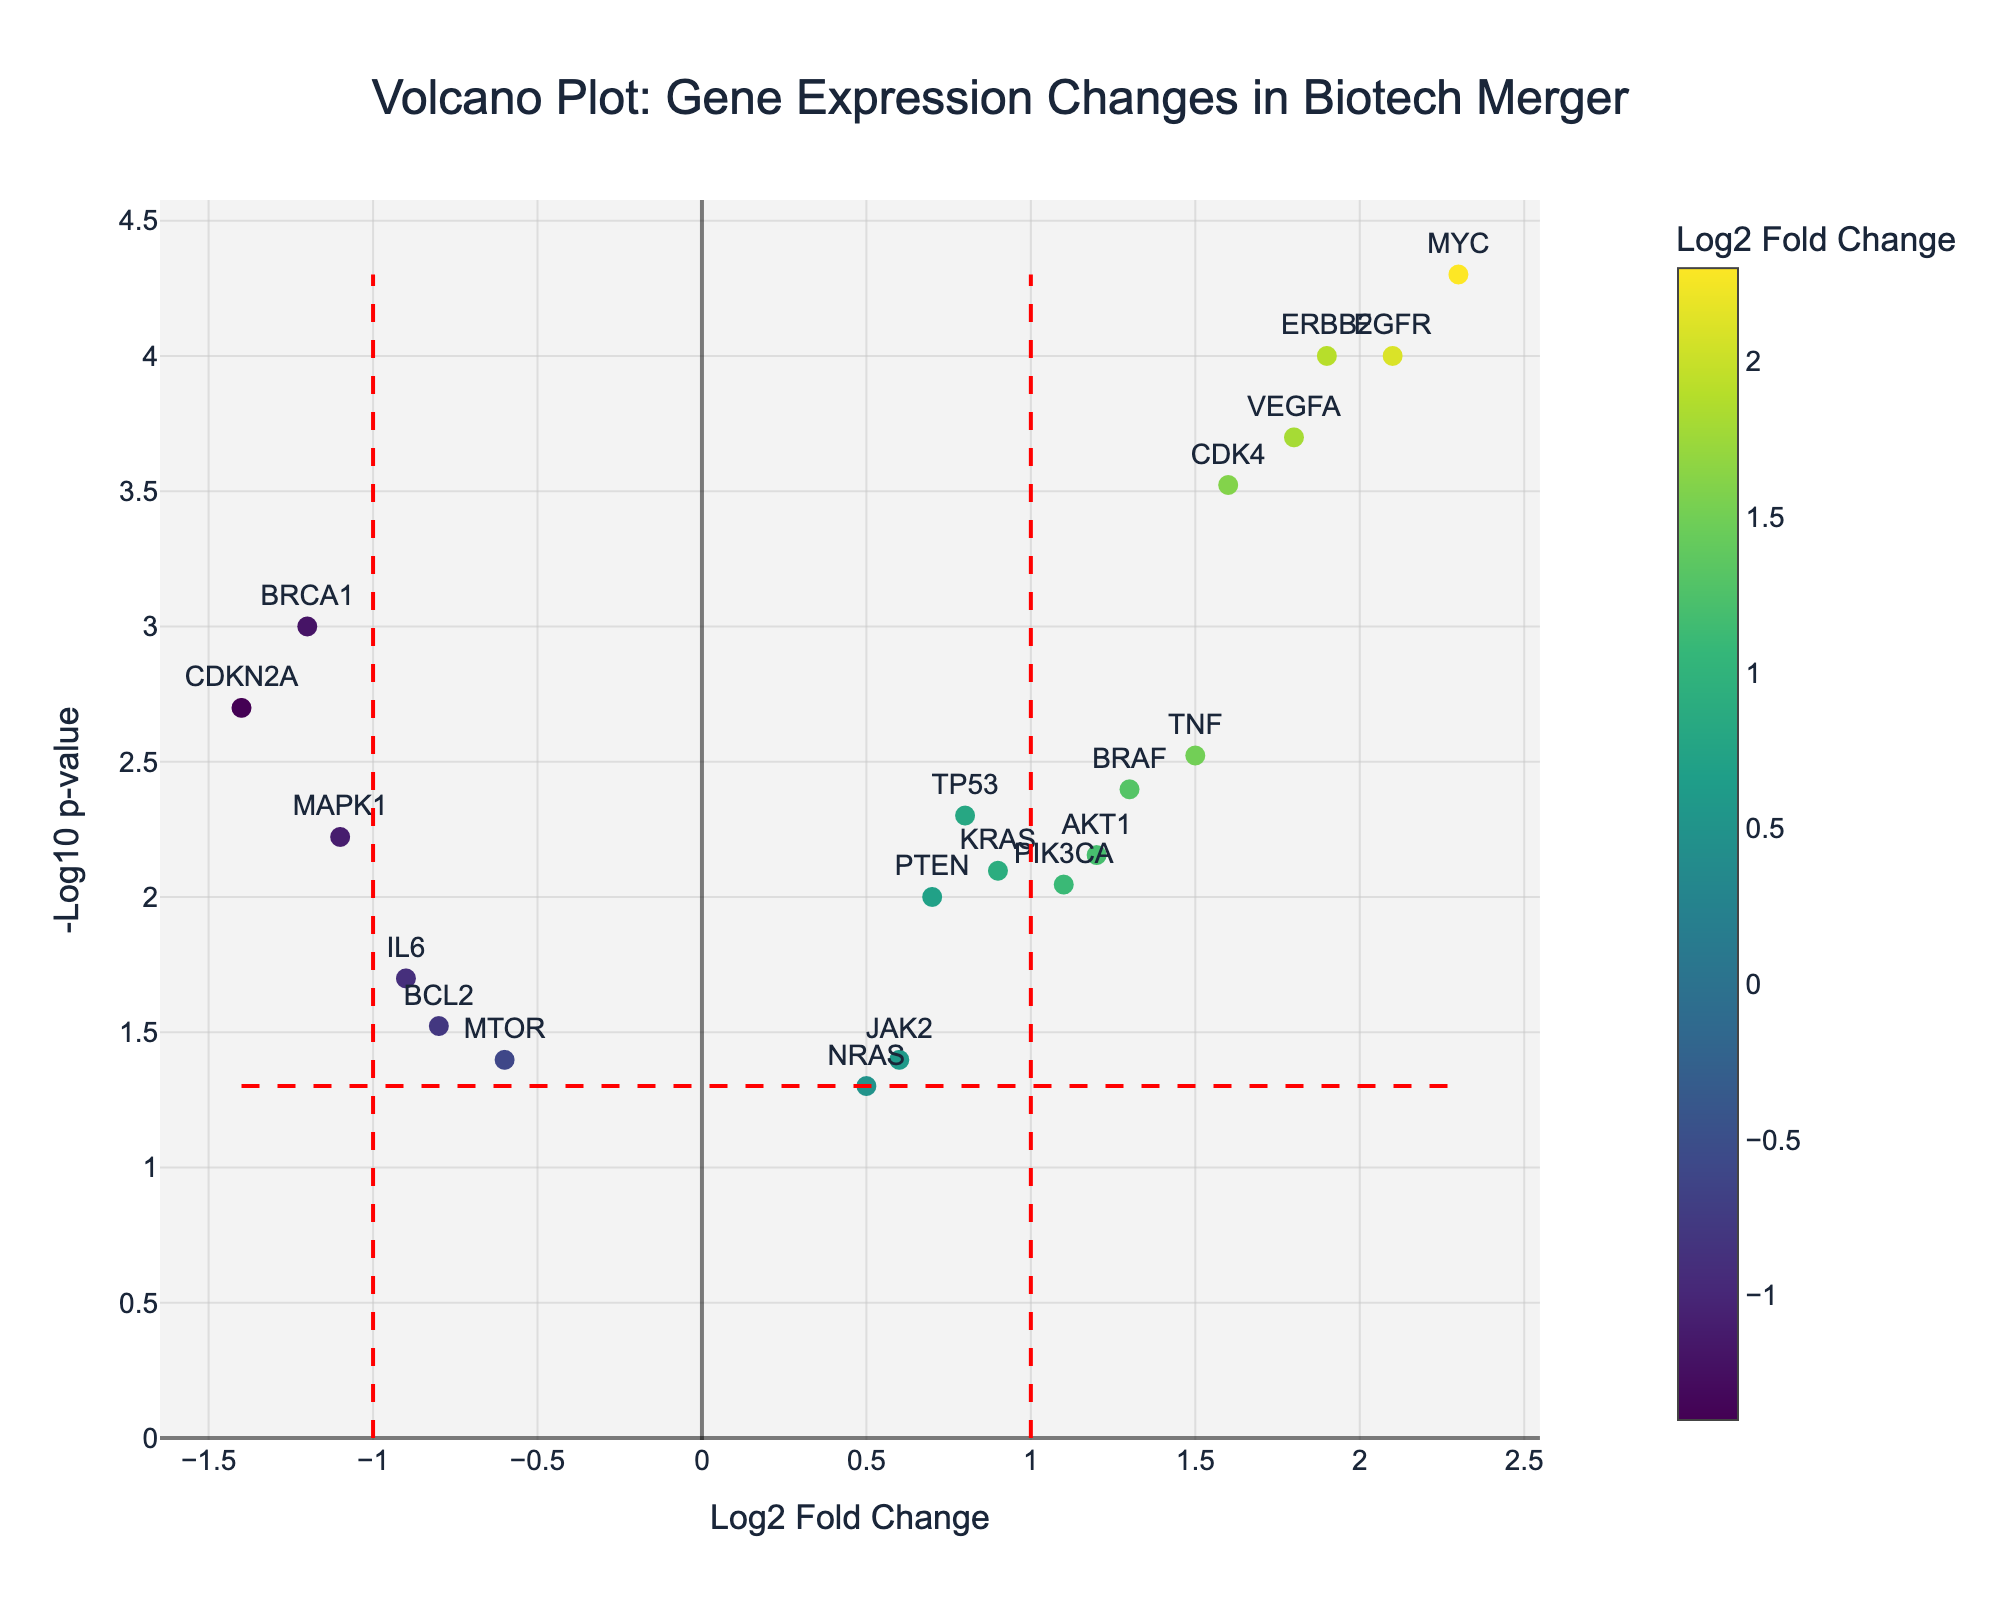What's the title of the plot? The title of the plot is placed at the top center and reads "Volcano Plot: Gene Expression Changes in Biotech Merger".
Answer: Volcano Plot: Gene Expression Changes in Biotech Merger What does the x-axis represent? The x-axis is labeled as "Log2 Fold Change" which indicates the log2 fold change in gene expression.
Answer: Log2 Fold Change How many genes have an increased expression after the merger? To identify genes with increased expression, look for those with a positive log2 fold change value.
Answer: 12 Which gene has the most statistically significant change? The gene with the lowest p-value will have the highest -log10(p-value). "MYC" stands out with a -log10(p-value) very high.
Answer: MYC Which gene has the highest increase in expression levels? To find the gene with the highest increase, locate the gene with the highest positive log2 fold change. "MYC" has the highest value of 2.3.
Answer: MYC Which gene with a log2 fold change less than 0 has the smallest p-value? Among genes with a negative log2 fold change, "BRCA1" has the highest -log10(p-value), indicating the smallest p-value.
Answer: BRCA1 Which genes fall outside the fold change threshold of log2 fold change >1 or < -1? Genes with log2 fold changes greater than 1 or less than -1 are highlighted by the red vertical lines: "EGFR", "TNF", "VEGFA", "AKT1", "CDK4", "MYC", "ERBB2", "CDKN2A", "BRCA1", "MAPK1".
Answer: 10 genes fall outside the thresholds How many genes have a p-value below 0.05? Genes above the horizontal red line (representing -log10(0.05)) have p-values below 0.05. This can also be counted from the data provided.
Answer: 18 genes Which gene has a log2 fold change closest to zero but is still statistically significant? Among genes with p-values below 0.05, "PTEN" has a log2 fold change of 0.7, which is closest to zero.
Answer: PTEN 